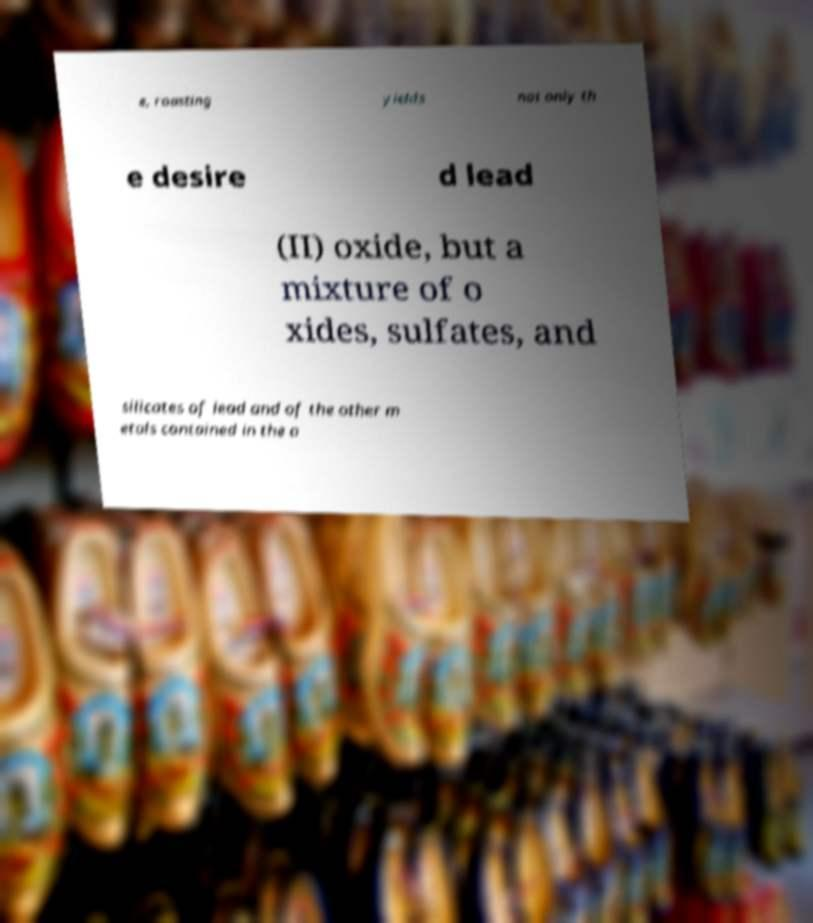What messages or text are displayed in this image? I need them in a readable, typed format. e, roasting yields not only th e desire d lead (II) oxide, but a mixture of o xides, sulfates, and silicates of lead and of the other m etals contained in the o 